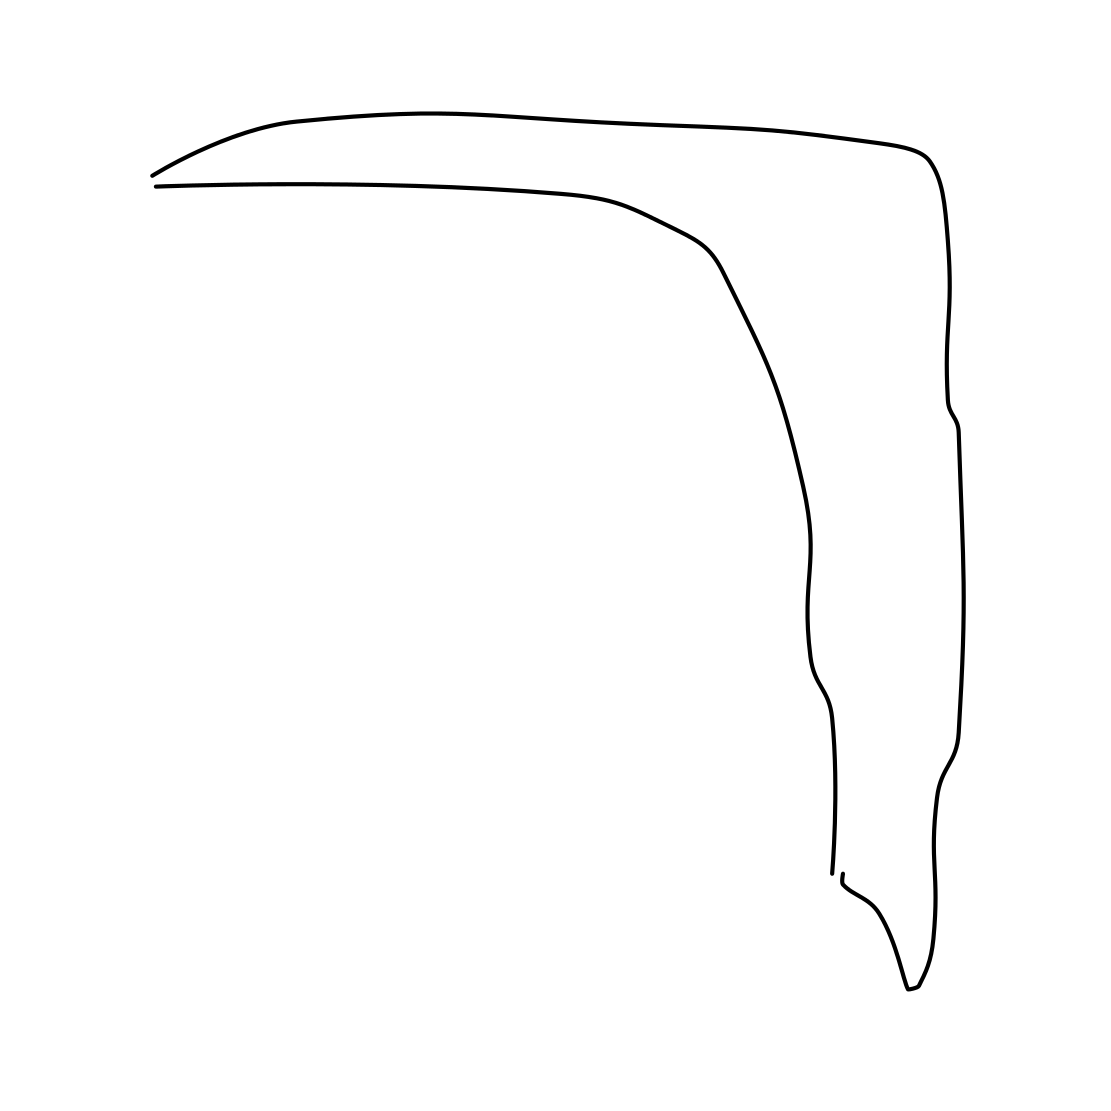Is this a head in the image? Yes, the image depicts a simple outline that resembles the profile of a human head. It captures the basic features such as the forehead, nose, lips, and chin in a minimalistic style. 